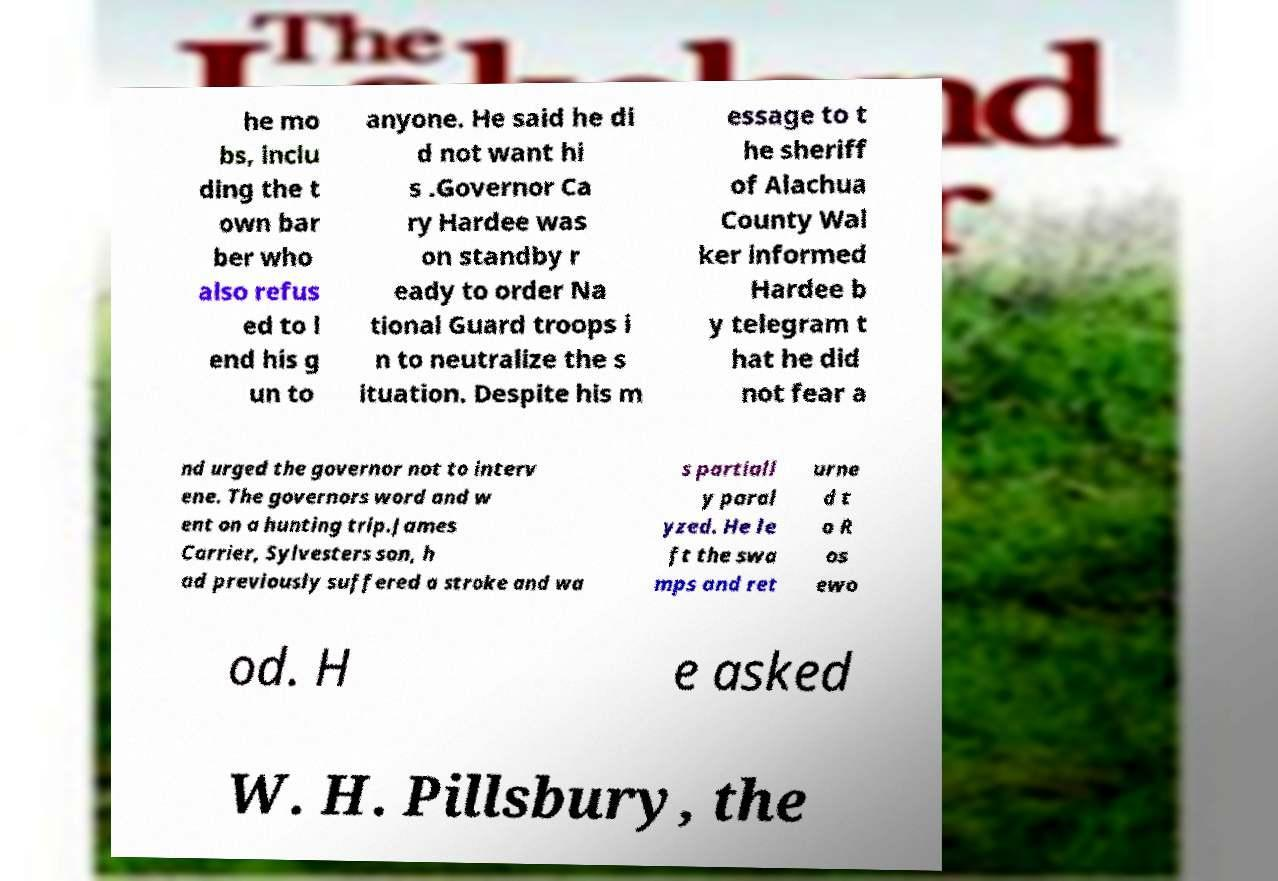Please identify and transcribe the text found in this image. he mo bs, inclu ding the t own bar ber who also refus ed to l end his g un to anyone. He said he di d not want hi s .Governor Ca ry Hardee was on standby r eady to order Na tional Guard troops i n to neutralize the s ituation. Despite his m essage to t he sheriff of Alachua County Wal ker informed Hardee b y telegram t hat he did not fear a nd urged the governor not to interv ene. The governors word and w ent on a hunting trip.James Carrier, Sylvesters son, h ad previously suffered a stroke and wa s partiall y paral yzed. He le ft the swa mps and ret urne d t o R os ewo od. H e asked W. H. Pillsbury, the 